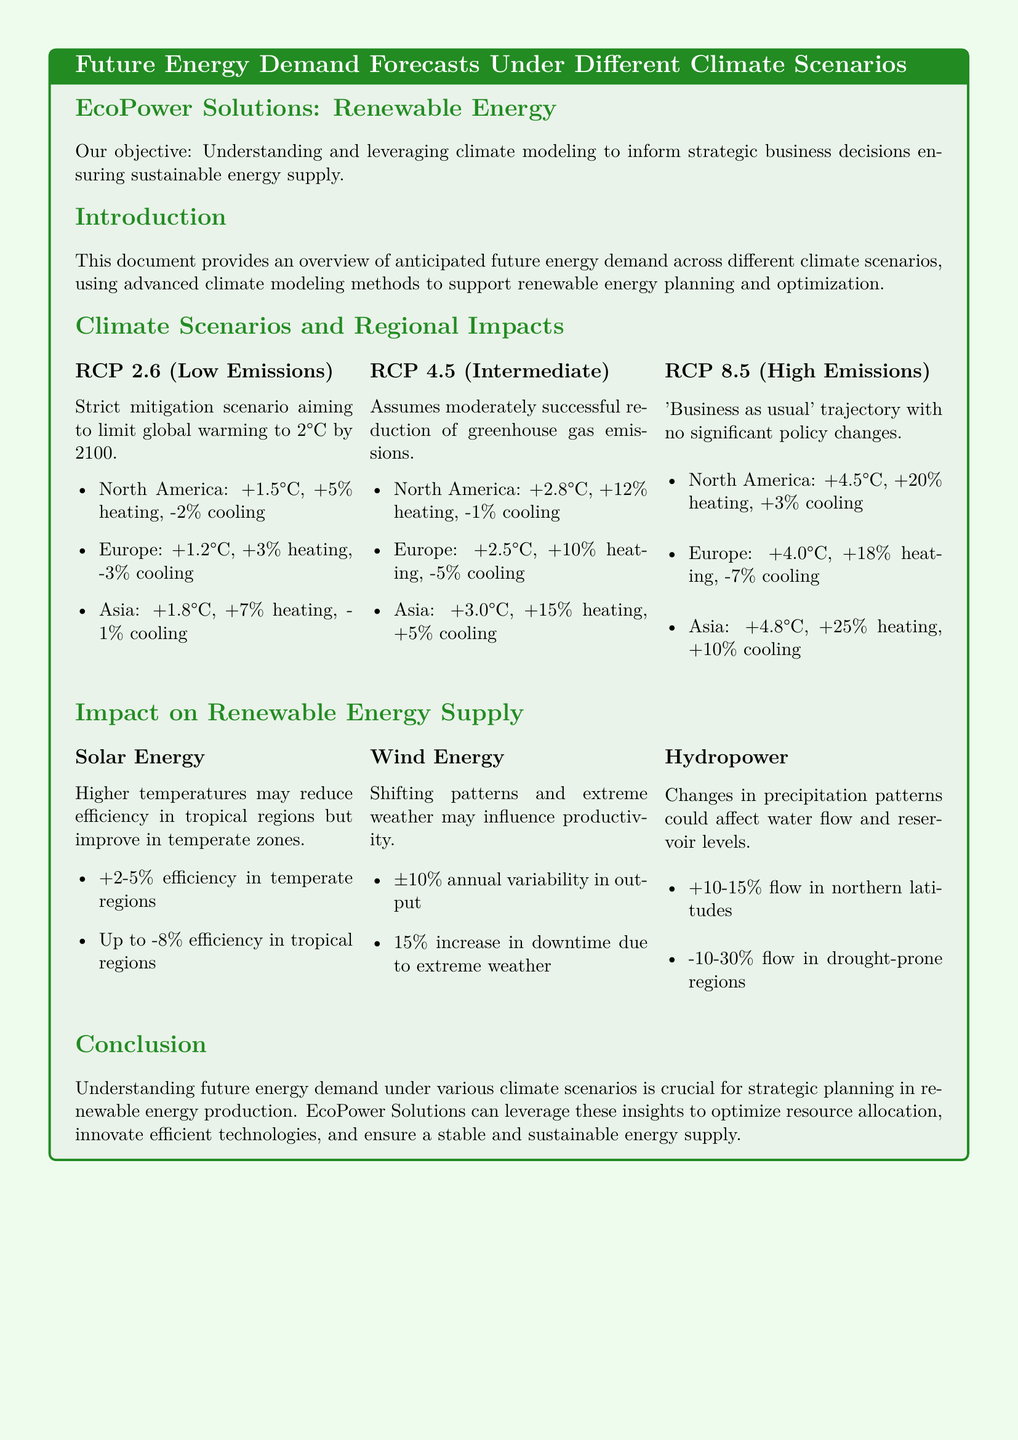What is EcoPower Solutions' objective? The objective is to understand and leverage climate modeling to inform strategic business decisions ensuring sustainable energy supply.
Answer: Understanding and leveraging climate modeling What temperature increase is projected for North America under RCP 2.6? Under RCP 2.6, North America is projected to have a temperature increase of +1.5°C.
Answer: +1.5°C What is the expected impact on hydropower flow in drought-prone regions? Drought-prone regions are expected to experience a flow decrease of -10-30%.
Answer: -10-30% Which climate scenario predicts a +20% increase in heating for North America? The RCP 8.5 scenario predicts this increase.
Answer: RCP 8.5 How does higher temperature affect solar energy efficiency in tropical regions? Higher temperatures may reduce efficiency in tropical regions by up to -8%.
Answer: Up to -8% What percentage of increase in downtime for wind energy is anticipated due to extreme weather? A 15% increase in downtime due to extreme weather is anticipated.
Answer: 15% What is the expected temperature rise for Europe under RCP 4.5? The expected temperature rise for Europe under RCP 4.5 is +2.5°C.
Answer: +2.5°C How can EcoPower Solutions utilize insights from future energy demand forecasts? They can use insights to optimize resource allocation, innovate efficient technologies, and ensure a stable and sustainable energy supply.
Answer: Optimize resource allocation What are the three renewable energy sources mentioned in the document? The three sources are solar energy, wind energy, and hydropower.
Answer: Solar energy, wind energy, hydropower What is the main focus of the product specification sheet? The main focus is to provide an overview of anticipated future energy demand across different climate scenarios.
Answer: Future energy demand forecasts 